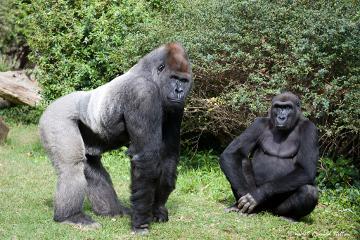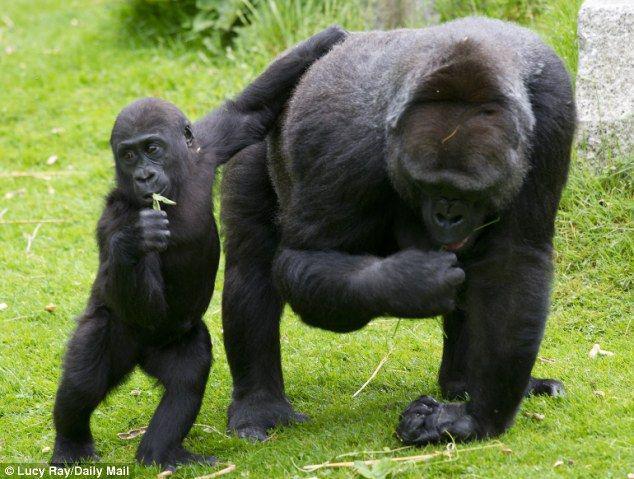The first image is the image on the left, the second image is the image on the right. Assess this claim about the two images: "All gorillas are standing on all fours, and no image contains more than one gorilla.". Correct or not? Answer yes or no. No. 